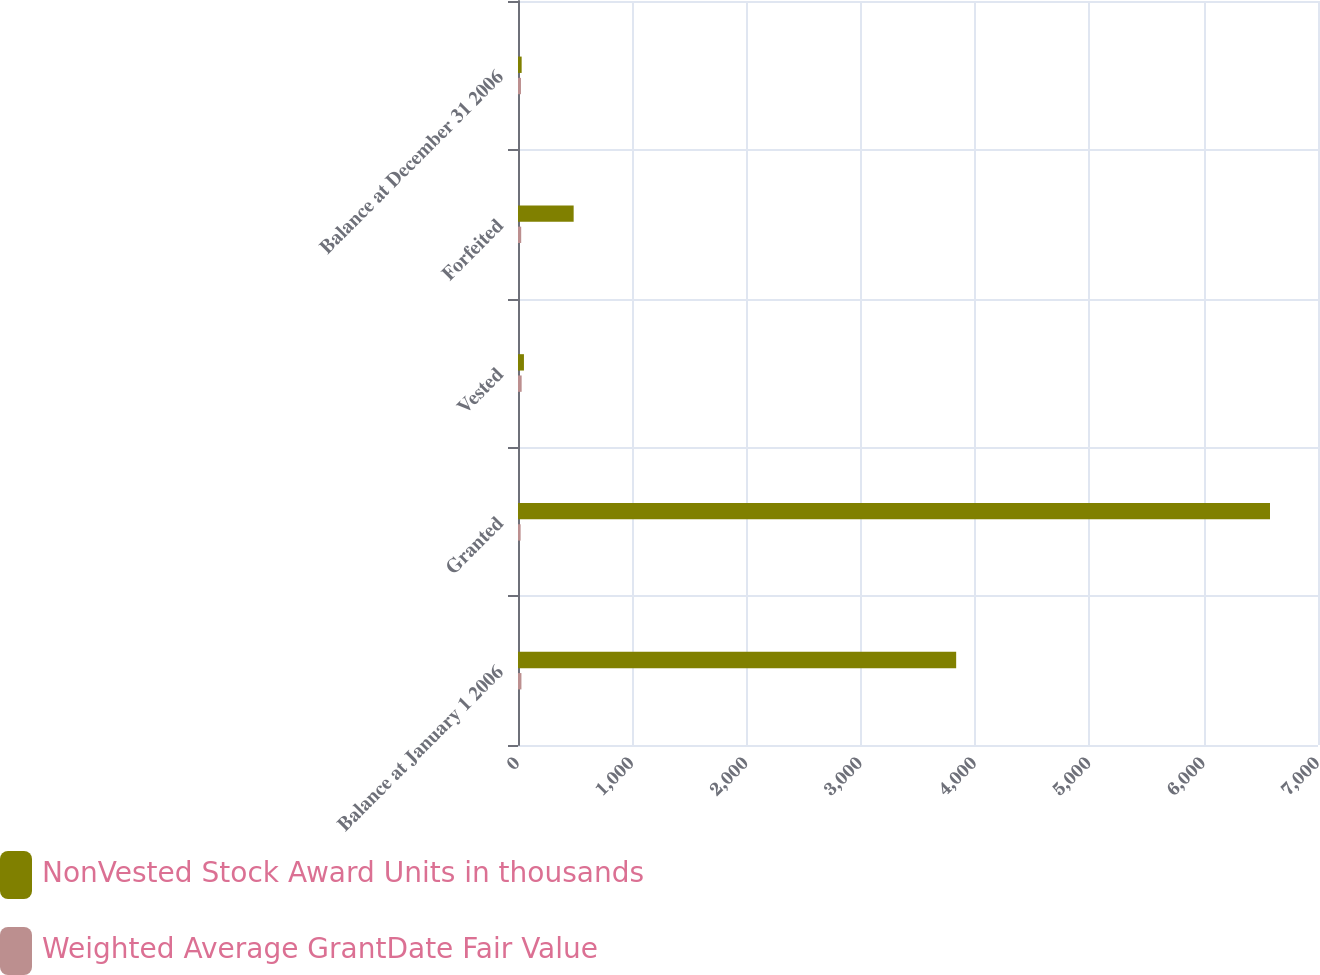Convert chart to OTSL. <chart><loc_0><loc_0><loc_500><loc_500><stacked_bar_chart><ecel><fcel>Balance at January 1 2006<fcel>Granted<fcel>Vested<fcel>Forfeited<fcel>Balance at December 31 2006<nl><fcel>NonVested Stock Award Units in thousands<fcel>3834<fcel>6580<fcel>52<fcel>487<fcel>32<nl><fcel>Weighted Average GrantDate Fair Value<fcel>30<fcel>23<fcel>32<fcel>28<fcel>26<nl></chart> 